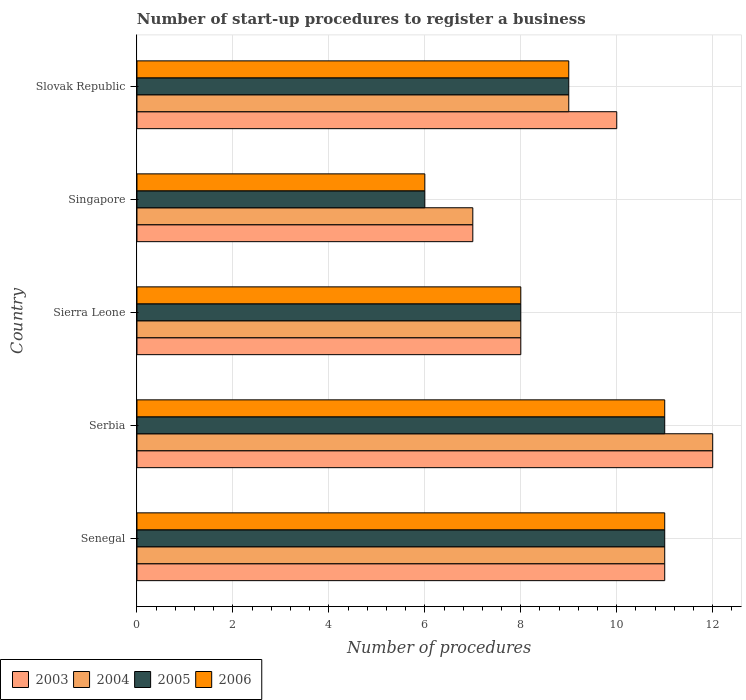How many different coloured bars are there?
Your answer should be compact. 4. How many groups of bars are there?
Offer a very short reply. 5. How many bars are there on the 4th tick from the top?
Provide a succinct answer. 4. What is the label of the 5th group of bars from the top?
Offer a very short reply. Senegal. What is the number of procedures required to register a business in 2003 in Serbia?
Provide a succinct answer. 12. In which country was the number of procedures required to register a business in 2006 maximum?
Make the answer very short. Senegal. In which country was the number of procedures required to register a business in 2004 minimum?
Give a very brief answer. Singapore. What is the average number of procedures required to register a business in 2004 per country?
Give a very brief answer. 9.4. What is the ratio of the number of procedures required to register a business in 2006 in Singapore to that in Slovak Republic?
Offer a terse response. 0.67. Is the number of procedures required to register a business in 2003 in Senegal less than that in Singapore?
Offer a terse response. No. Is the difference between the number of procedures required to register a business in 2004 in Senegal and Slovak Republic greater than the difference between the number of procedures required to register a business in 2005 in Senegal and Slovak Republic?
Your answer should be compact. No. What is the difference between the highest and the second highest number of procedures required to register a business in 2006?
Your answer should be compact. 0. Is it the case that in every country, the sum of the number of procedures required to register a business in 2004 and number of procedures required to register a business in 2006 is greater than the sum of number of procedures required to register a business in 2005 and number of procedures required to register a business in 2003?
Offer a terse response. No. What does the 1st bar from the top in Slovak Republic represents?
Offer a very short reply. 2006. How many bars are there?
Offer a very short reply. 20. How many countries are there in the graph?
Your response must be concise. 5. Are the values on the major ticks of X-axis written in scientific E-notation?
Provide a succinct answer. No. Does the graph contain grids?
Provide a succinct answer. Yes. How are the legend labels stacked?
Keep it short and to the point. Horizontal. What is the title of the graph?
Ensure brevity in your answer.  Number of start-up procedures to register a business. What is the label or title of the X-axis?
Offer a very short reply. Number of procedures. What is the Number of procedures of 2005 in Senegal?
Your response must be concise. 11. What is the Number of procedures in 2003 in Serbia?
Make the answer very short. 12. What is the Number of procedures in 2004 in Serbia?
Your answer should be very brief. 12. What is the Number of procedures in 2005 in Serbia?
Offer a terse response. 11. What is the Number of procedures of 2006 in Serbia?
Your response must be concise. 11. What is the Number of procedures of 2004 in Sierra Leone?
Your response must be concise. 8. What is the Number of procedures of 2005 in Sierra Leone?
Make the answer very short. 8. What is the Number of procedures of 2003 in Singapore?
Your response must be concise. 7. What is the Number of procedures in 2005 in Singapore?
Give a very brief answer. 6. What is the Number of procedures of 2006 in Singapore?
Offer a terse response. 6. What is the Number of procedures in 2003 in Slovak Republic?
Make the answer very short. 10. What is the Number of procedures in 2004 in Slovak Republic?
Your answer should be compact. 9. What is the Number of procedures of 2005 in Slovak Republic?
Provide a short and direct response. 9. What is the Number of procedures of 2006 in Slovak Republic?
Offer a terse response. 9. Across all countries, what is the maximum Number of procedures in 2003?
Your answer should be compact. 12. Across all countries, what is the maximum Number of procedures in 2006?
Provide a short and direct response. 11. Across all countries, what is the minimum Number of procedures of 2004?
Your answer should be compact. 7. Across all countries, what is the minimum Number of procedures in 2005?
Provide a succinct answer. 6. Across all countries, what is the minimum Number of procedures in 2006?
Keep it short and to the point. 6. What is the total Number of procedures of 2003 in the graph?
Your answer should be very brief. 48. What is the total Number of procedures of 2004 in the graph?
Provide a short and direct response. 47. What is the total Number of procedures in 2006 in the graph?
Offer a terse response. 45. What is the difference between the Number of procedures in 2003 in Senegal and that in Serbia?
Your answer should be very brief. -1. What is the difference between the Number of procedures in 2006 in Senegal and that in Serbia?
Provide a short and direct response. 0. What is the difference between the Number of procedures of 2005 in Senegal and that in Sierra Leone?
Keep it short and to the point. 3. What is the difference between the Number of procedures in 2006 in Senegal and that in Sierra Leone?
Provide a succinct answer. 3. What is the difference between the Number of procedures of 2004 in Senegal and that in Singapore?
Your response must be concise. 4. What is the difference between the Number of procedures of 2003 in Senegal and that in Slovak Republic?
Ensure brevity in your answer.  1. What is the difference between the Number of procedures in 2004 in Senegal and that in Slovak Republic?
Keep it short and to the point. 2. What is the difference between the Number of procedures of 2005 in Senegal and that in Slovak Republic?
Make the answer very short. 2. What is the difference between the Number of procedures in 2006 in Senegal and that in Slovak Republic?
Make the answer very short. 2. What is the difference between the Number of procedures of 2003 in Serbia and that in Sierra Leone?
Provide a succinct answer. 4. What is the difference between the Number of procedures of 2005 in Serbia and that in Sierra Leone?
Provide a short and direct response. 3. What is the difference between the Number of procedures in 2006 in Serbia and that in Sierra Leone?
Provide a short and direct response. 3. What is the difference between the Number of procedures in 2005 in Serbia and that in Singapore?
Offer a terse response. 5. What is the difference between the Number of procedures in 2005 in Serbia and that in Slovak Republic?
Keep it short and to the point. 2. What is the difference between the Number of procedures in 2006 in Serbia and that in Slovak Republic?
Give a very brief answer. 2. What is the difference between the Number of procedures of 2004 in Sierra Leone and that in Slovak Republic?
Your response must be concise. -1. What is the difference between the Number of procedures in 2005 in Sierra Leone and that in Slovak Republic?
Keep it short and to the point. -1. What is the difference between the Number of procedures in 2003 in Singapore and that in Slovak Republic?
Provide a short and direct response. -3. What is the difference between the Number of procedures of 2005 in Singapore and that in Slovak Republic?
Make the answer very short. -3. What is the difference between the Number of procedures of 2006 in Singapore and that in Slovak Republic?
Offer a very short reply. -3. What is the difference between the Number of procedures of 2003 in Senegal and the Number of procedures of 2004 in Serbia?
Make the answer very short. -1. What is the difference between the Number of procedures in 2003 in Senegal and the Number of procedures in 2006 in Serbia?
Provide a succinct answer. 0. What is the difference between the Number of procedures of 2004 in Senegal and the Number of procedures of 2006 in Serbia?
Keep it short and to the point. 0. What is the difference between the Number of procedures in 2005 in Senegal and the Number of procedures in 2006 in Serbia?
Ensure brevity in your answer.  0. What is the difference between the Number of procedures of 2003 in Senegal and the Number of procedures of 2004 in Sierra Leone?
Your response must be concise. 3. What is the difference between the Number of procedures in 2004 in Senegal and the Number of procedures in 2005 in Sierra Leone?
Ensure brevity in your answer.  3. What is the difference between the Number of procedures in 2005 in Senegal and the Number of procedures in 2006 in Sierra Leone?
Provide a succinct answer. 3. What is the difference between the Number of procedures in 2004 in Senegal and the Number of procedures in 2005 in Singapore?
Provide a short and direct response. 5. What is the difference between the Number of procedures in 2005 in Senegal and the Number of procedures in 2006 in Singapore?
Your answer should be compact. 5. What is the difference between the Number of procedures in 2004 in Senegal and the Number of procedures in 2005 in Slovak Republic?
Offer a terse response. 2. What is the difference between the Number of procedures of 2004 in Senegal and the Number of procedures of 2006 in Slovak Republic?
Keep it short and to the point. 2. What is the difference between the Number of procedures in 2005 in Senegal and the Number of procedures in 2006 in Slovak Republic?
Your answer should be compact. 2. What is the difference between the Number of procedures in 2003 in Serbia and the Number of procedures in 2005 in Sierra Leone?
Offer a very short reply. 4. What is the difference between the Number of procedures in 2003 in Serbia and the Number of procedures in 2006 in Sierra Leone?
Your response must be concise. 4. What is the difference between the Number of procedures of 2004 in Serbia and the Number of procedures of 2005 in Sierra Leone?
Provide a short and direct response. 4. What is the difference between the Number of procedures of 2005 in Serbia and the Number of procedures of 2006 in Sierra Leone?
Give a very brief answer. 3. What is the difference between the Number of procedures of 2003 in Serbia and the Number of procedures of 2004 in Singapore?
Keep it short and to the point. 5. What is the difference between the Number of procedures in 2003 in Serbia and the Number of procedures in 2006 in Singapore?
Your answer should be very brief. 6. What is the difference between the Number of procedures in 2004 in Serbia and the Number of procedures in 2006 in Singapore?
Keep it short and to the point. 6. What is the difference between the Number of procedures in 2003 in Serbia and the Number of procedures in 2004 in Slovak Republic?
Your answer should be very brief. 3. What is the difference between the Number of procedures in 2004 in Serbia and the Number of procedures in 2006 in Slovak Republic?
Give a very brief answer. 3. What is the difference between the Number of procedures in 2005 in Serbia and the Number of procedures in 2006 in Slovak Republic?
Ensure brevity in your answer.  2. What is the difference between the Number of procedures of 2003 in Sierra Leone and the Number of procedures of 2005 in Singapore?
Your answer should be very brief. 2. What is the difference between the Number of procedures in 2004 in Sierra Leone and the Number of procedures in 2005 in Singapore?
Give a very brief answer. 2. What is the difference between the Number of procedures in 2004 in Sierra Leone and the Number of procedures in 2006 in Singapore?
Make the answer very short. 2. What is the difference between the Number of procedures of 2005 in Sierra Leone and the Number of procedures of 2006 in Singapore?
Your response must be concise. 2. What is the difference between the Number of procedures in 2003 in Sierra Leone and the Number of procedures in 2004 in Slovak Republic?
Your answer should be compact. -1. What is the difference between the Number of procedures in 2003 in Sierra Leone and the Number of procedures in 2006 in Slovak Republic?
Your answer should be compact. -1. What is the difference between the Number of procedures in 2004 in Sierra Leone and the Number of procedures in 2006 in Slovak Republic?
Your response must be concise. -1. What is the difference between the Number of procedures in 2005 in Sierra Leone and the Number of procedures in 2006 in Slovak Republic?
Provide a succinct answer. -1. What is the difference between the Number of procedures in 2003 in Singapore and the Number of procedures in 2004 in Slovak Republic?
Provide a succinct answer. -2. What is the difference between the Number of procedures of 2003 in Singapore and the Number of procedures of 2005 in Slovak Republic?
Make the answer very short. -2. What is the difference between the Number of procedures in 2003 in Singapore and the Number of procedures in 2006 in Slovak Republic?
Offer a very short reply. -2. What is the difference between the Number of procedures of 2004 in Singapore and the Number of procedures of 2006 in Slovak Republic?
Provide a short and direct response. -2. What is the difference between the Number of procedures of 2005 in Singapore and the Number of procedures of 2006 in Slovak Republic?
Keep it short and to the point. -3. What is the average Number of procedures in 2003 per country?
Provide a short and direct response. 9.6. What is the difference between the Number of procedures of 2003 and Number of procedures of 2004 in Senegal?
Keep it short and to the point. 0. What is the difference between the Number of procedures of 2003 and Number of procedures of 2006 in Senegal?
Make the answer very short. 0. What is the difference between the Number of procedures of 2003 and Number of procedures of 2004 in Serbia?
Provide a short and direct response. 0. What is the difference between the Number of procedures in 2004 and Number of procedures in 2006 in Serbia?
Give a very brief answer. 1. What is the difference between the Number of procedures of 2005 and Number of procedures of 2006 in Serbia?
Provide a succinct answer. 0. What is the difference between the Number of procedures in 2003 and Number of procedures in 2004 in Sierra Leone?
Give a very brief answer. 0. What is the difference between the Number of procedures of 2003 and Number of procedures of 2006 in Sierra Leone?
Your answer should be very brief. 0. What is the difference between the Number of procedures of 2004 and Number of procedures of 2006 in Sierra Leone?
Offer a very short reply. 0. What is the difference between the Number of procedures of 2005 and Number of procedures of 2006 in Sierra Leone?
Your answer should be very brief. 0. What is the difference between the Number of procedures of 2003 and Number of procedures of 2006 in Singapore?
Your answer should be compact. 1. What is the difference between the Number of procedures of 2004 and Number of procedures of 2005 in Singapore?
Make the answer very short. 1. What is the difference between the Number of procedures in 2005 and Number of procedures in 2006 in Singapore?
Keep it short and to the point. 0. What is the difference between the Number of procedures in 2003 and Number of procedures in 2006 in Slovak Republic?
Your response must be concise. 1. What is the difference between the Number of procedures of 2004 and Number of procedures of 2005 in Slovak Republic?
Offer a very short reply. 0. What is the ratio of the Number of procedures in 2004 in Senegal to that in Serbia?
Offer a very short reply. 0.92. What is the ratio of the Number of procedures of 2003 in Senegal to that in Sierra Leone?
Offer a very short reply. 1.38. What is the ratio of the Number of procedures of 2004 in Senegal to that in Sierra Leone?
Keep it short and to the point. 1.38. What is the ratio of the Number of procedures in 2005 in Senegal to that in Sierra Leone?
Your answer should be very brief. 1.38. What is the ratio of the Number of procedures in 2006 in Senegal to that in Sierra Leone?
Give a very brief answer. 1.38. What is the ratio of the Number of procedures of 2003 in Senegal to that in Singapore?
Offer a very short reply. 1.57. What is the ratio of the Number of procedures in 2004 in Senegal to that in Singapore?
Provide a succinct answer. 1.57. What is the ratio of the Number of procedures in 2005 in Senegal to that in Singapore?
Offer a terse response. 1.83. What is the ratio of the Number of procedures of 2006 in Senegal to that in Singapore?
Offer a very short reply. 1.83. What is the ratio of the Number of procedures in 2003 in Senegal to that in Slovak Republic?
Make the answer very short. 1.1. What is the ratio of the Number of procedures of 2004 in Senegal to that in Slovak Republic?
Make the answer very short. 1.22. What is the ratio of the Number of procedures in 2005 in Senegal to that in Slovak Republic?
Your response must be concise. 1.22. What is the ratio of the Number of procedures of 2006 in Senegal to that in Slovak Republic?
Ensure brevity in your answer.  1.22. What is the ratio of the Number of procedures of 2003 in Serbia to that in Sierra Leone?
Offer a very short reply. 1.5. What is the ratio of the Number of procedures in 2004 in Serbia to that in Sierra Leone?
Give a very brief answer. 1.5. What is the ratio of the Number of procedures in 2005 in Serbia to that in Sierra Leone?
Your response must be concise. 1.38. What is the ratio of the Number of procedures of 2006 in Serbia to that in Sierra Leone?
Make the answer very short. 1.38. What is the ratio of the Number of procedures of 2003 in Serbia to that in Singapore?
Provide a short and direct response. 1.71. What is the ratio of the Number of procedures in 2004 in Serbia to that in Singapore?
Offer a terse response. 1.71. What is the ratio of the Number of procedures of 2005 in Serbia to that in Singapore?
Your response must be concise. 1.83. What is the ratio of the Number of procedures in 2006 in Serbia to that in Singapore?
Ensure brevity in your answer.  1.83. What is the ratio of the Number of procedures of 2003 in Serbia to that in Slovak Republic?
Offer a terse response. 1.2. What is the ratio of the Number of procedures in 2005 in Serbia to that in Slovak Republic?
Make the answer very short. 1.22. What is the ratio of the Number of procedures in 2006 in Serbia to that in Slovak Republic?
Your response must be concise. 1.22. What is the ratio of the Number of procedures of 2003 in Sierra Leone to that in Singapore?
Your response must be concise. 1.14. What is the ratio of the Number of procedures in 2004 in Sierra Leone to that in Singapore?
Provide a short and direct response. 1.14. What is the ratio of the Number of procedures of 2005 in Sierra Leone to that in Singapore?
Keep it short and to the point. 1.33. What is the ratio of the Number of procedures in 2006 in Sierra Leone to that in Singapore?
Ensure brevity in your answer.  1.33. What is the ratio of the Number of procedures in 2003 in Sierra Leone to that in Slovak Republic?
Keep it short and to the point. 0.8. What is the ratio of the Number of procedures of 2004 in Sierra Leone to that in Slovak Republic?
Your response must be concise. 0.89. What is the ratio of the Number of procedures of 2005 in Sierra Leone to that in Slovak Republic?
Your answer should be compact. 0.89. What is the ratio of the Number of procedures in 2006 in Sierra Leone to that in Slovak Republic?
Offer a very short reply. 0.89. What is the ratio of the Number of procedures in 2003 in Singapore to that in Slovak Republic?
Your answer should be very brief. 0.7. What is the ratio of the Number of procedures in 2005 in Singapore to that in Slovak Republic?
Make the answer very short. 0.67. What is the ratio of the Number of procedures in 2006 in Singapore to that in Slovak Republic?
Offer a terse response. 0.67. What is the difference between the highest and the second highest Number of procedures of 2003?
Ensure brevity in your answer.  1. What is the difference between the highest and the second highest Number of procedures of 2005?
Give a very brief answer. 0. What is the difference between the highest and the second highest Number of procedures in 2006?
Your answer should be compact. 0. What is the difference between the highest and the lowest Number of procedures of 2004?
Offer a very short reply. 5. What is the difference between the highest and the lowest Number of procedures of 2005?
Provide a succinct answer. 5. What is the difference between the highest and the lowest Number of procedures of 2006?
Give a very brief answer. 5. 